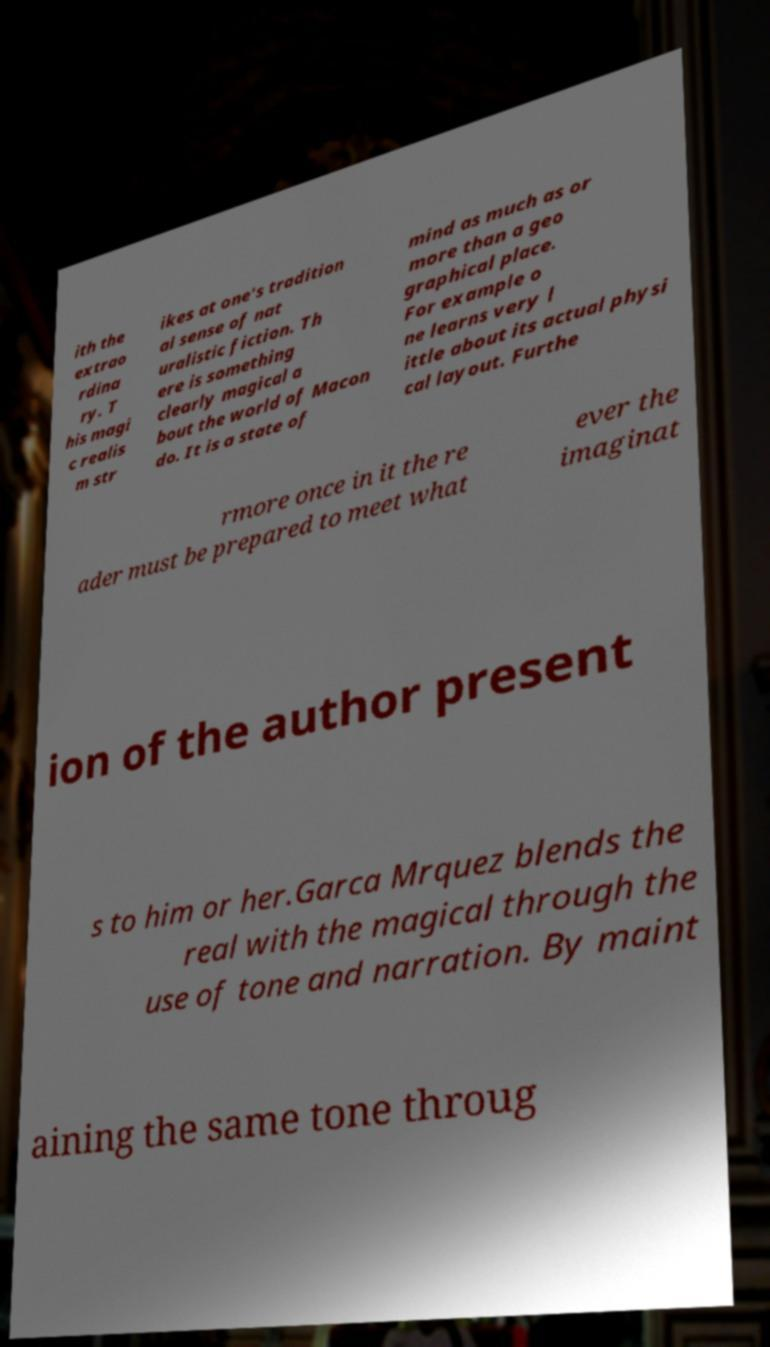Can you accurately transcribe the text from the provided image for me? ith the extrao rdina ry. T his magi c realis m str ikes at one's tradition al sense of nat uralistic fiction. Th ere is something clearly magical a bout the world of Macon do. It is a state of mind as much as or more than a geo graphical place. For example o ne learns very l ittle about its actual physi cal layout. Furthe rmore once in it the re ader must be prepared to meet what ever the imaginat ion of the author present s to him or her.Garca Mrquez blends the real with the magical through the use of tone and narration. By maint aining the same tone throug 